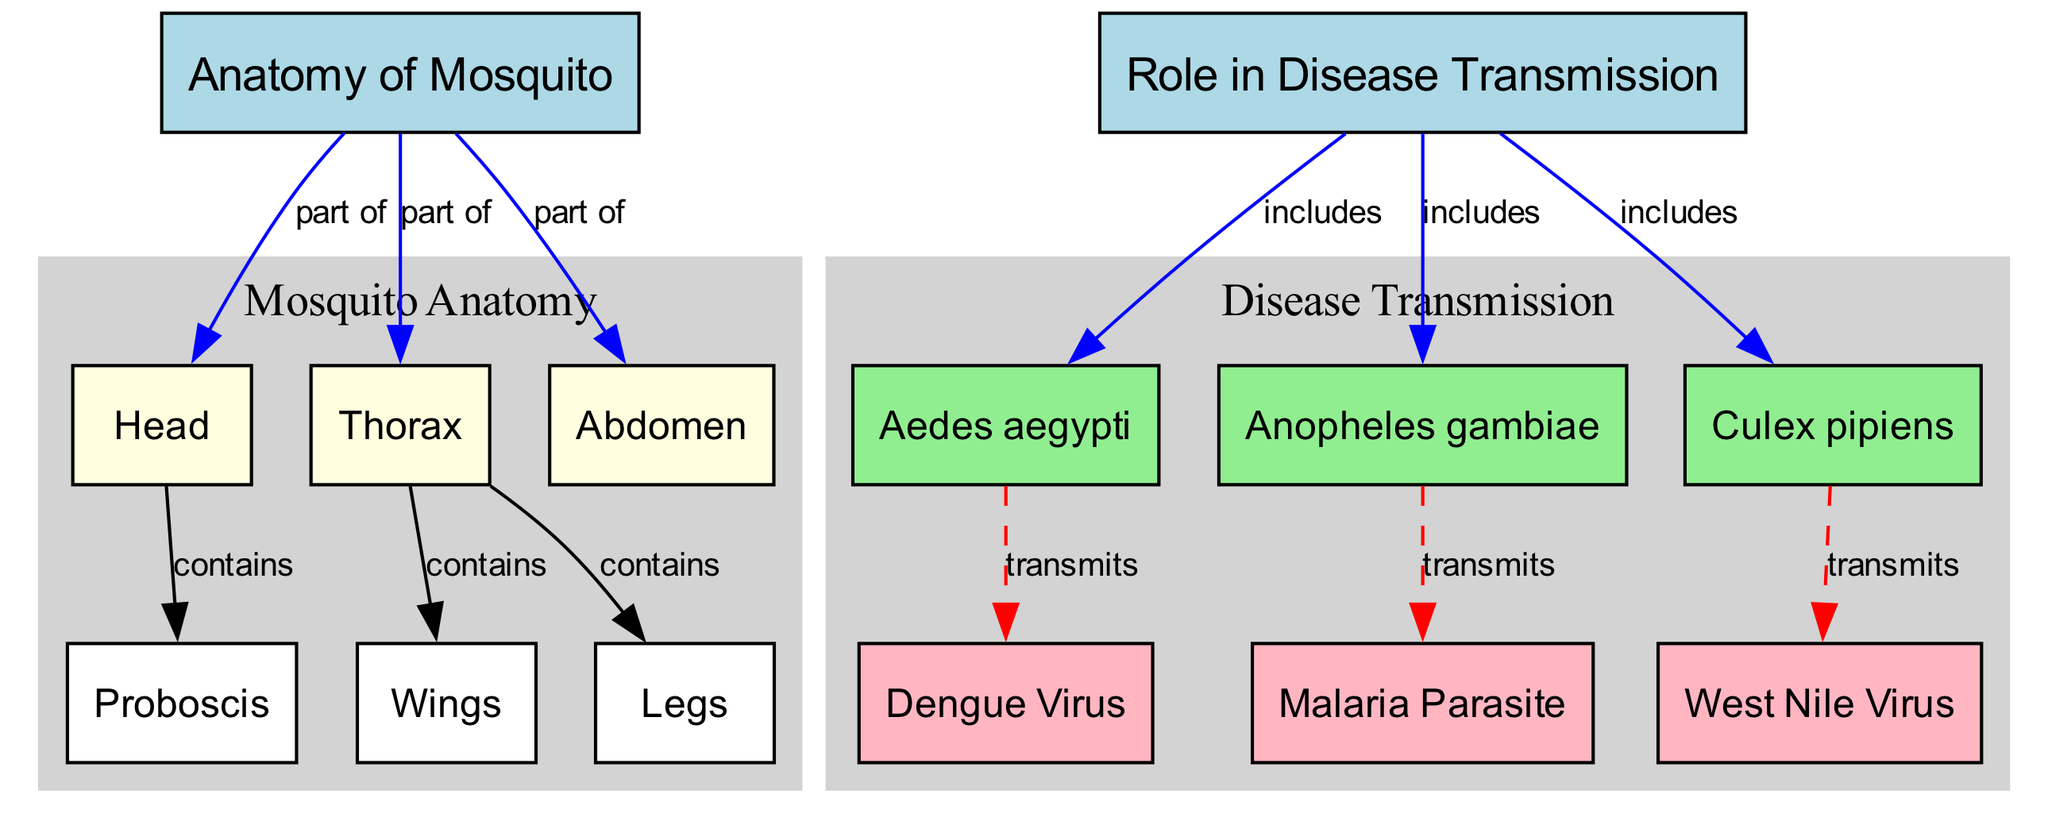What are the three main body parts of a mosquito? The diagram lists the main body parts of a mosquito as Head, Thorax, and Abdomen, which are directly connected as part of the Anatomy of Mosquito.
Answer: Head, Thorax, Abdomen Which structure contains the proboscis? The diagram indicates that the Head contains the Proboscis, as shown by the directed edge connecting the two in the structure of the anatomy.
Answer: Head How many types of mosquitoes are included in the role of disease transmission? From the diagram, there are three types of mosquitoes identified in the Role in Disease Transmission: Aedes aegypti, Anopheles gambiae, and Culex pipiens, which can be counted directly from the nodes connected to the Role in Disease Transmission.
Answer: 3 Which virus is transmitted by Aedes aegypti? The directed edge from Aedes aegypti leads to the Dengue Virus in the disease transmission section of the diagram, signifying its role as a vector for this specific virus.
Answer: Dengue Virus What color is used to represent the anatomical features of the mosquito? The anatomical nodes (Head, Thorax, Abdomen, Proboscis, Wings, and Legs) are colored light yellow in the diagram, which is a distinct color choice for this category compared to the other categories.
Answer: Light Yellow What is the relationship between Anopheles gambiae and the malaria parasite? The diagram shows a directed edge from Anopheles gambiae to Malaria Parasite, indicating that Anopheles gambiae transmits the Malaria Parasite, illustrating a direct connection in terms of disease transmission.
Answer: Transmits Which mosquito is represented in light green? The types of mosquitoes, Aedes aegypti, Anopheles gambiae, and Culex pipiens, are colored light green according to the diagram, which is distinctive to vectors of disease transmission.
Answer: Aedes aegypti, Anopheles gambiae, Culex pipiens How many viruses are listed in the disease transmission section? The diagram lists three viruses: Dengue Virus, Malaria Parasite, and West Nile Virus, which are connected to the corresponding mosquito vectors, making it straightforward to count them from the diagram.
Answer: 3 